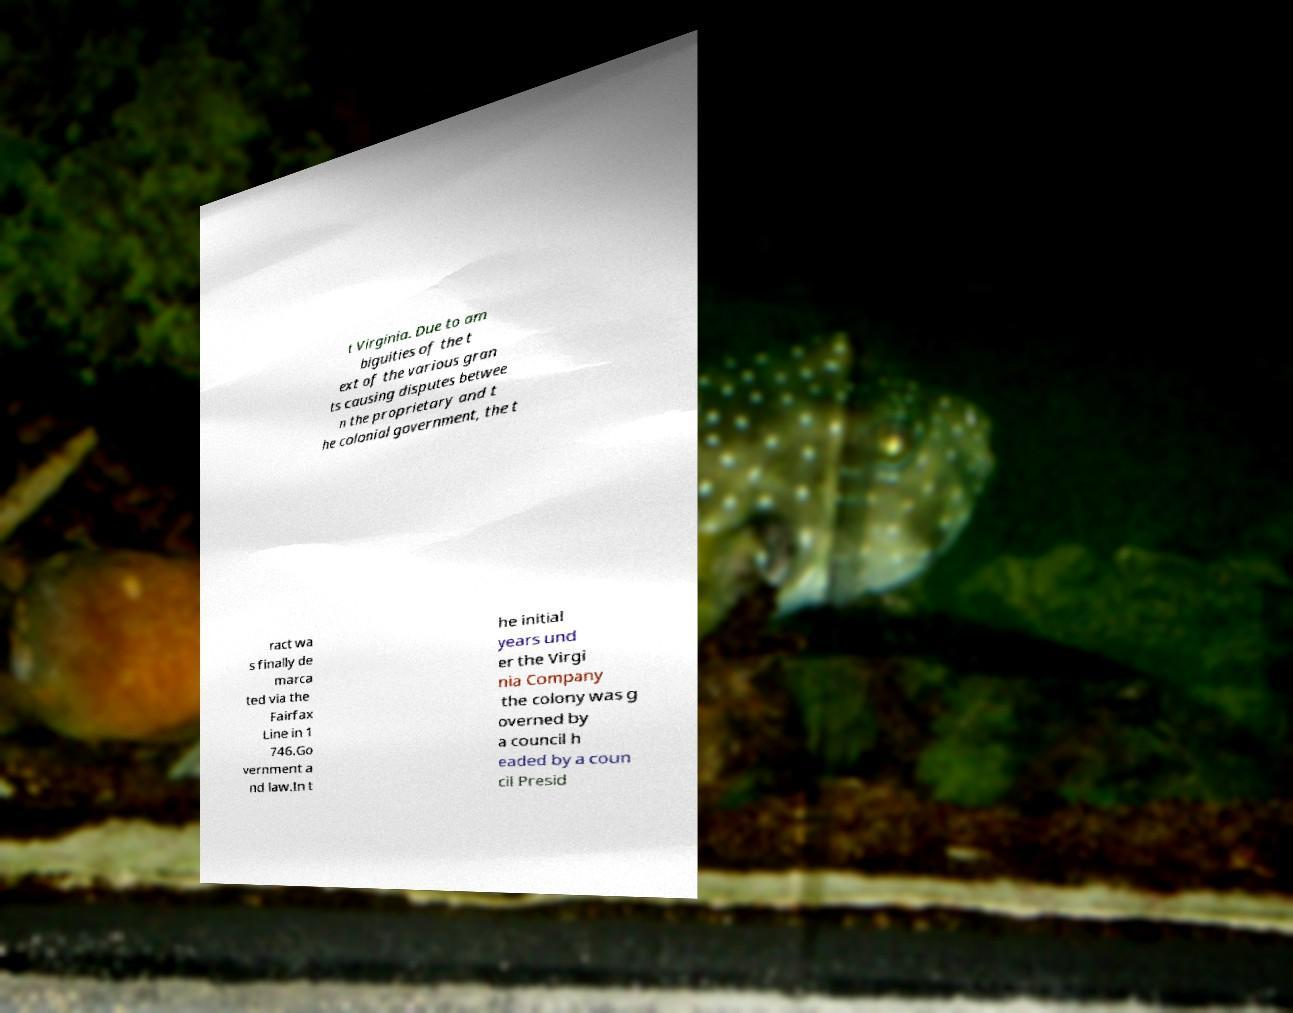For documentation purposes, I need the text within this image transcribed. Could you provide that? t Virginia. Due to am biguities of the t ext of the various gran ts causing disputes betwee n the proprietary and t he colonial government, the t ract wa s finally de marca ted via the Fairfax Line in 1 746.Go vernment a nd law.In t he initial years und er the Virgi nia Company the colony was g overned by a council h eaded by a coun cil Presid 